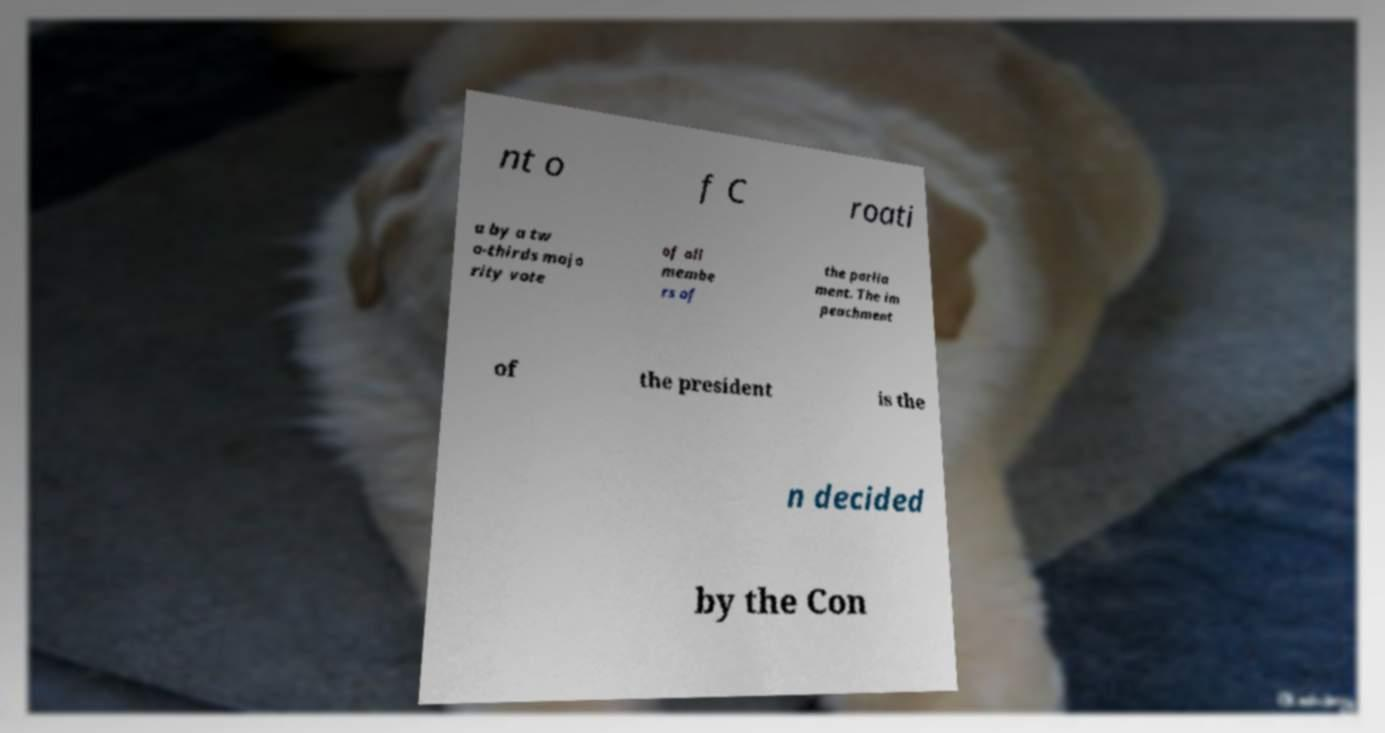Could you extract and type out the text from this image? nt o f C roati a by a tw o-thirds majo rity vote of all membe rs of the parlia ment. The im peachment of the president is the n decided by the Con 